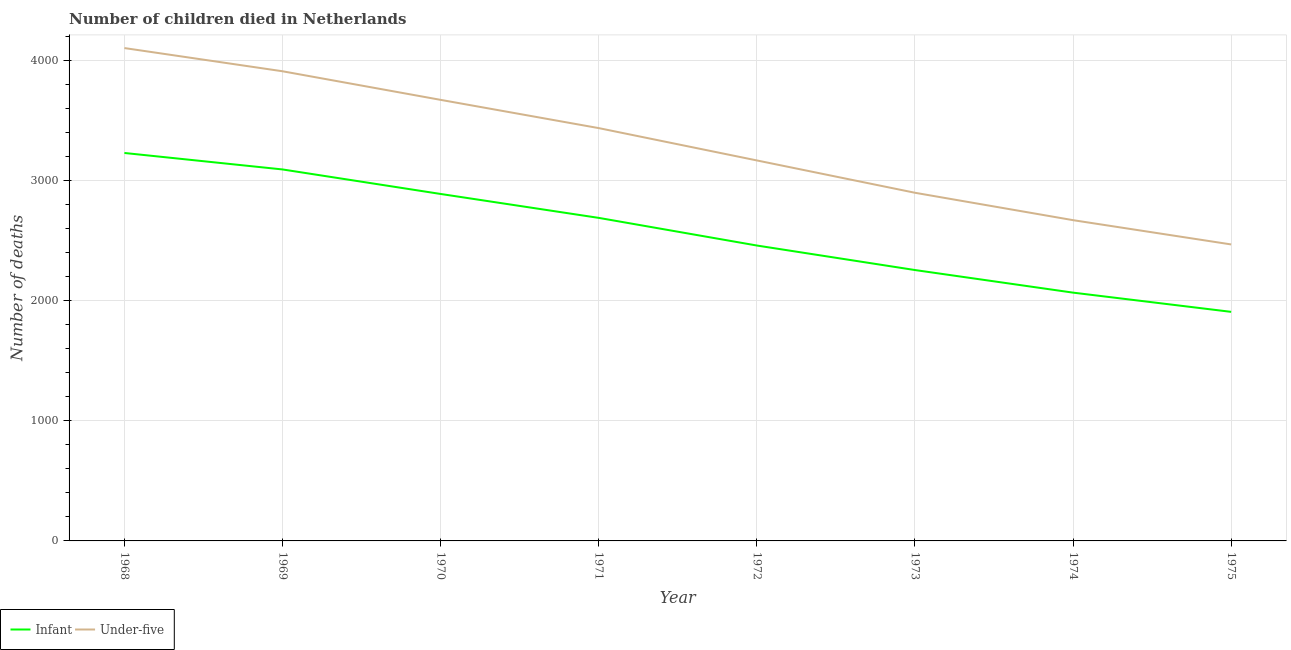Is the number of lines equal to the number of legend labels?
Offer a very short reply. Yes. What is the number of infant deaths in 1970?
Offer a terse response. 2887. Across all years, what is the maximum number of under-five deaths?
Provide a succinct answer. 4101. Across all years, what is the minimum number of under-five deaths?
Give a very brief answer. 2467. In which year was the number of infant deaths maximum?
Offer a very short reply. 1968. In which year was the number of infant deaths minimum?
Give a very brief answer. 1975. What is the total number of under-five deaths in the graph?
Ensure brevity in your answer.  2.63e+04. What is the difference between the number of infant deaths in 1968 and that in 1973?
Ensure brevity in your answer.  974. What is the difference between the number of infant deaths in 1971 and the number of under-five deaths in 1975?
Offer a terse response. 221. What is the average number of under-five deaths per year?
Provide a short and direct response. 3289.12. In the year 1972, what is the difference between the number of under-five deaths and number of infant deaths?
Keep it short and to the point. 708. What is the ratio of the number of under-five deaths in 1973 to that in 1975?
Ensure brevity in your answer.  1.17. Is the number of infant deaths in 1969 less than that in 1970?
Ensure brevity in your answer.  No. Is the difference between the number of under-five deaths in 1974 and 1975 greater than the difference between the number of infant deaths in 1974 and 1975?
Offer a very short reply. Yes. What is the difference between the highest and the second highest number of infant deaths?
Provide a succinct answer. 137. What is the difference between the highest and the lowest number of infant deaths?
Offer a very short reply. 1322. In how many years, is the number of infant deaths greater than the average number of infant deaths taken over all years?
Provide a short and direct response. 4. Is the sum of the number of infant deaths in 1969 and 1973 greater than the maximum number of under-five deaths across all years?
Make the answer very short. Yes. Does the number of infant deaths monotonically increase over the years?
Give a very brief answer. No. Is the number of under-five deaths strictly greater than the number of infant deaths over the years?
Ensure brevity in your answer.  Yes. How many lines are there?
Ensure brevity in your answer.  2. How many years are there in the graph?
Offer a very short reply. 8. What is the difference between two consecutive major ticks on the Y-axis?
Ensure brevity in your answer.  1000. Does the graph contain grids?
Offer a terse response. Yes. Where does the legend appear in the graph?
Provide a short and direct response. Bottom left. How many legend labels are there?
Offer a terse response. 2. How are the legend labels stacked?
Provide a short and direct response. Horizontal. What is the title of the graph?
Ensure brevity in your answer.  Number of children died in Netherlands. What is the label or title of the X-axis?
Keep it short and to the point. Year. What is the label or title of the Y-axis?
Your response must be concise. Number of deaths. What is the Number of deaths of Infant in 1968?
Offer a very short reply. 3228. What is the Number of deaths of Under-five in 1968?
Your response must be concise. 4101. What is the Number of deaths of Infant in 1969?
Your response must be concise. 3091. What is the Number of deaths in Under-five in 1969?
Your answer should be compact. 3908. What is the Number of deaths in Infant in 1970?
Offer a terse response. 2887. What is the Number of deaths in Under-five in 1970?
Offer a terse response. 3670. What is the Number of deaths in Infant in 1971?
Provide a short and direct response. 2688. What is the Number of deaths in Under-five in 1971?
Ensure brevity in your answer.  3435. What is the Number of deaths of Infant in 1972?
Your response must be concise. 2458. What is the Number of deaths of Under-five in 1972?
Your answer should be very brief. 3166. What is the Number of deaths in Infant in 1973?
Ensure brevity in your answer.  2254. What is the Number of deaths in Under-five in 1973?
Make the answer very short. 2897. What is the Number of deaths of Infant in 1974?
Give a very brief answer. 2066. What is the Number of deaths of Under-five in 1974?
Your response must be concise. 2669. What is the Number of deaths in Infant in 1975?
Your answer should be compact. 1906. What is the Number of deaths of Under-five in 1975?
Give a very brief answer. 2467. Across all years, what is the maximum Number of deaths of Infant?
Ensure brevity in your answer.  3228. Across all years, what is the maximum Number of deaths in Under-five?
Provide a short and direct response. 4101. Across all years, what is the minimum Number of deaths of Infant?
Offer a terse response. 1906. Across all years, what is the minimum Number of deaths in Under-five?
Provide a succinct answer. 2467. What is the total Number of deaths in Infant in the graph?
Ensure brevity in your answer.  2.06e+04. What is the total Number of deaths in Under-five in the graph?
Provide a succinct answer. 2.63e+04. What is the difference between the Number of deaths of Infant in 1968 and that in 1969?
Ensure brevity in your answer.  137. What is the difference between the Number of deaths of Under-five in 1968 and that in 1969?
Your response must be concise. 193. What is the difference between the Number of deaths in Infant in 1968 and that in 1970?
Your answer should be compact. 341. What is the difference between the Number of deaths in Under-five in 1968 and that in 1970?
Make the answer very short. 431. What is the difference between the Number of deaths of Infant in 1968 and that in 1971?
Offer a terse response. 540. What is the difference between the Number of deaths of Under-five in 1968 and that in 1971?
Provide a short and direct response. 666. What is the difference between the Number of deaths of Infant in 1968 and that in 1972?
Your answer should be compact. 770. What is the difference between the Number of deaths in Under-five in 1968 and that in 1972?
Your answer should be very brief. 935. What is the difference between the Number of deaths in Infant in 1968 and that in 1973?
Offer a terse response. 974. What is the difference between the Number of deaths in Under-five in 1968 and that in 1973?
Provide a short and direct response. 1204. What is the difference between the Number of deaths of Infant in 1968 and that in 1974?
Your answer should be very brief. 1162. What is the difference between the Number of deaths in Under-five in 1968 and that in 1974?
Provide a succinct answer. 1432. What is the difference between the Number of deaths in Infant in 1968 and that in 1975?
Provide a short and direct response. 1322. What is the difference between the Number of deaths in Under-five in 1968 and that in 1975?
Ensure brevity in your answer.  1634. What is the difference between the Number of deaths of Infant in 1969 and that in 1970?
Offer a terse response. 204. What is the difference between the Number of deaths of Under-five in 1969 and that in 1970?
Keep it short and to the point. 238. What is the difference between the Number of deaths of Infant in 1969 and that in 1971?
Your answer should be compact. 403. What is the difference between the Number of deaths of Under-five in 1969 and that in 1971?
Offer a terse response. 473. What is the difference between the Number of deaths of Infant in 1969 and that in 1972?
Ensure brevity in your answer.  633. What is the difference between the Number of deaths of Under-five in 1969 and that in 1972?
Give a very brief answer. 742. What is the difference between the Number of deaths in Infant in 1969 and that in 1973?
Offer a very short reply. 837. What is the difference between the Number of deaths in Under-five in 1969 and that in 1973?
Make the answer very short. 1011. What is the difference between the Number of deaths in Infant in 1969 and that in 1974?
Ensure brevity in your answer.  1025. What is the difference between the Number of deaths in Under-five in 1969 and that in 1974?
Offer a terse response. 1239. What is the difference between the Number of deaths of Infant in 1969 and that in 1975?
Keep it short and to the point. 1185. What is the difference between the Number of deaths in Under-five in 1969 and that in 1975?
Your answer should be very brief. 1441. What is the difference between the Number of deaths of Infant in 1970 and that in 1971?
Your answer should be very brief. 199. What is the difference between the Number of deaths of Under-five in 1970 and that in 1971?
Keep it short and to the point. 235. What is the difference between the Number of deaths of Infant in 1970 and that in 1972?
Offer a terse response. 429. What is the difference between the Number of deaths in Under-five in 1970 and that in 1972?
Make the answer very short. 504. What is the difference between the Number of deaths in Infant in 1970 and that in 1973?
Your answer should be very brief. 633. What is the difference between the Number of deaths of Under-five in 1970 and that in 1973?
Offer a terse response. 773. What is the difference between the Number of deaths of Infant in 1970 and that in 1974?
Your answer should be very brief. 821. What is the difference between the Number of deaths in Under-five in 1970 and that in 1974?
Provide a succinct answer. 1001. What is the difference between the Number of deaths of Infant in 1970 and that in 1975?
Provide a short and direct response. 981. What is the difference between the Number of deaths in Under-five in 1970 and that in 1975?
Give a very brief answer. 1203. What is the difference between the Number of deaths in Infant in 1971 and that in 1972?
Offer a very short reply. 230. What is the difference between the Number of deaths in Under-five in 1971 and that in 1972?
Make the answer very short. 269. What is the difference between the Number of deaths in Infant in 1971 and that in 1973?
Provide a succinct answer. 434. What is the difference between the Number of deaths in Under-five in 1971 and that in 1973?
Your answer should be compact. 538. What is the difference between the Number of deaths of Infant in 1971 and that in 1974?
Give a very brief answer. 622. What is the difference between the Number of deaths of Under-five in 1971 and that in 1974?
Provide a succinct answer. 766. What is the difference between the Number of deaths in Infant in 1971 and that in 1975?
Offer a terse response. 782. What is the difference between the Number of deaths of Under-five in 1971 and that in 1975?
Your answer should be very brief. 968. What is the difference between the Number of deaths in Infant in 1972 and that in 1973?
Your answer should be compact. 204. What is the difference between the Number of deaths in Under-five in 1972 and that in 1973?
Your answer should be very brief. 269. What is the difference between the Number of deaths in Infant in 1972 and that in 1974?
Provide a succinct answer. 392. What is the difference between the Number of deaths in Under-five in 1972 and that in 1974?
Your answer should be very brief. 497. What is the difference between the Number of deaths in Infant in 1972 and that in 1975?
Your response must be concise. 552. What is the difference between the Number of deaths in Under-five in 1972 and that in 1975?
Your answer should be very brief. 699. What is the difference between the Number of deaths of Infant in 1973 and that in 1974?
Your response must be concise. 188. What is the difference between the Number of deaths in Under-five in 1973 and that in 1974?
Ensure brevity in your answer.  228. What is the difference between the Number of deaths of Infant in 1973 and that in 1975?
Ensure brevity in your answer.  348. What is the difference between the Number of deaths in Under-five in 1973 and that in 1975?
Keep it short and to the point. 430. What is the difference between the Number of deaths in Infant in 1974 and that in 1975?
Your answer should be compact. 160. What is the difference between the Number of deaths of Under-five in 1974 and that in 1975?
Your response must be concise. 202. What is the difference between the Number of deaths in Infant in 1968 and the Number of deaths in Under-five in 1969?
Keep it short and to the point. -680. What is the difference between the Number of deaths of Infant in 1968 and the Number of deaths of Under-five in 1970?
Offer a very short reply. -442. What is the difference between the Number of deaths in Infant in 1968 and the Number of deaths in Under-five in 1971?
Give a very brief answer. -207. What is the difference between the Number of deaths of Infant in 1968 and the Number of deaths of Under-five in 1973?
Provide a short and direct response. 331. What is the difference between the Number of deaths in Infant in 1968 and the Number of deaths in Under-five in 1974?
Provide a short and direct response. 559. What is the difference between the Number of deaths in Infant in 1968 and the Number of deaths in Under-five in 1975?
Ensure brevity in your answer.  761. What is the difference between the Number of deaths in Infant in 1969 and the Number of deaths in Under-five in 1970?
Your answer should be very brief. -579. What is the difference between the Number of deaths of Infant in 1969 and the Number of deaths of Under-five in 1971?
Offer a very short reply. -344. What is the difference between the Number of deaths of Infant in 1969 and the Number of deaths of Under-five in 1972?
Give a very brief answer. -75. What is the difference between the Number of deaths in Infant in 1969 and the Number of deaths in Under-five in 1973?
Your response must be concise. 194. What is the difference between the Number of deaths in Infant in 1969 and the Number of deaths in Under-five in 1974?
Make the answer very short. 422. What is the difference between the Number of deaths of Infant in 1969 and the Number of deaths of Under-five in 1975?
Provide a short and direct response. 624. What is the difference between the Number of deaths in Infant in 1970 and the Number of deaths in Under-five in 1971?
Give a very brief answer. -548. What is the difference between the Number of deaths of Infant in 1970 and the Number of deaths of Under-five in 1972?
Offer a very short reply. -279. What is the difference between the Number of deaths of Infant in 1970 and the Number of deaths of Under-five in 1973?
Provide a short and direct response. -10. What is the difference between the Number of deaths of Infant in 1970 and the Number of deaths of Under-five in 1974?
Ensure brevity in your answer.  218. What is the difference between the Number of deaths of Infant in 1970 and the Number of deaths of Under-five in 1975?
Provide a succinct answer. 420. What is the difference between the Number of deaths of Infant in 1971 and the Number of deaths of Under-five in 1972?
Provide a succinct answer. -478. What is the difference between the Number of deaths of Infant in 1971 and the Number of deaths of Under-five in 1973?
Give a very brief answer. -209. What is the difference between the Number of deaths of Infant in 1971 and the Number of deaths of Under-five in 1974?
Your answer should be compact. 19. What is the difference between the Number of deaths in Infant in 1971 and the Number of deaths in Under-five in 1975?
Offer a terse response. 221. What is the difference between the Number of deaths in Infant in 1972 and the Number of deaths in Under-five in 1973?
Provide a succinct answer. -439. What is the difference between the Number of deaths of Infant in 1972 and the Number of deaths of Under-five in 1974?
Keep it short and to the point. -211. What is the difference between the Number of deaths of Infant in 1973 and the Number of deaths of Under-five in 1974?
Keep it short and to the point. -415. What is the difference between the Number of deaths of Infant in 1973 and the Number of deaths of Under-five in 1975?
Give a very brief answer. -213. What is the difference between the Number of deaths in Infant in 1974 and the Number of deaths in Under-five in 1975?
Keep it short and to the point. -401. What is the average Number of deaths in Infant per year?
Your response must be concise. 2572.25. What is the average Number of deaths of Under-five per year?
Keep it short and to the point. 3289.12. In the year 1968, what is the difference between the Number of deaths in Infant and Number of deaths in Under-five?
Provide a succinct answer. -873. In the year 1969, what is the difference between the Number of deaths in Infant and Number of deaths in Under-five?
Provide a succinct answer. -817. In the year 1970, what is the difference between the Number of deaths in Infant and Number of deaths in Under-five?
Give a very brief answer. -783. In the year 1971, what is the difference between the Number of deaths in Infant and Number of deaths in Under-five?
Make the answer very short. -747. In the year 1972, what is the difference between the Number of deaths in Infant and Number of deaths in Under-five?
Offer a terse response. -708. In the year 1973, what is the difference between the Number of deaths of Infant and Number of deaths of Under-five?
Make the answer very short. -643. In the year 1974, what is the difference between the Number of deaths of Infant and Number of deaths of Under-five?
Your response must be concise. -603. In the year 1975, what is the difference between the Number of deaths of Infant and Number of deaths of Under-five?
Keep it short and to the point. -561. What is the ratio of the Number of deaths in Infant in 1968 to that in 1969?
Offer a terse response. 1.04. What is the ratio of the Number of deaths in Under-five in 1968 to that in 1969?
Your response must be concise. 1.05. What is the ratio of the Number of deaths in Infant in 1968 to that in 1970?
Your response must be concise. 1.12. What is the ratio of the Number of deaths in Under-five in 1968 to that in 1970?
Offer a very short reply. 1.12. What is the ratio of the Number of deaths of Infant in 1968 to that in 1971?
Your answer should be compact. 1.2. What is the ratio of the Number of deaths of Under-five in 1968 to that in 1971?
Your answer should be compact. 1.19. What is the ratio of the Number of deaths of Infant in 1968 to that in 1972?
Provide a succinct answer. 1.31. What is the ratio of the Number of deaths of Under-five in 1968 to that in 1972?
Provide a short and direct response. 1.3. What is the ratio of the Number of deaths in Infant in 1968 to that in 1973?
Provide a succinct answer. 1.43. What is the ratio of the Number of deaths in Under-five in 1968 to that in 1973?
Ensure brevity in your answer.  1.42. What is the ratio of the Number of deaths of Infant in 1968 to that in 1974?
Give a very brief answer. 1.56. What is the ratio of the Number of deaths in Under-five in 1968 to that in 1974?
Give a very brief answer. 1.54. What is the ratio of the Number of deaths in Infant in 1968 to that in 1975?
Ensure brevity in your answer.  1.69. What is the ratio of the Number of deaths of Under-five in 1968 to that in 1975?
Keep it short and to the point. 1.66. What is the ratio of the Number of deaths in Infant in 1969 to that in 1970?
Your answer should be very brief. 1.07. What is the ratio of the Number of deaths in Under-five in 1969 to that in 1970?
Offer a very short reply. 1.06. What is the ratio of the Number of deaths in Infant in 1969 to that in 1971?
Your answer should be compact. 1.15. What is the ratio of the Number of deaths in Under-five in 1969 to that in 1971?
Provide a succinct answer. 1.14. What is the ratio of the Number of deaths of Infant in 1969 to that in 1972?
Your answer should be compact. 1.26. What is the ratio of the Number of deaths in Under-five in 1969 to that in 1972?
Your answer should be compact. 1.23. What is the ratio of the Number of deaths of Infant in 1969 to that in 1973?
Offer a very short reply. 1.37. What is the ratio of the Number of deaths in Under-five in 1969 to that in 1973?
Offer a very short reply. 1.35. What is the ratio of the Number of deaths of Infant in 1969 to that in 1974?
Your answer should be compact. 1.5. What is the ratio of the Number of deaths in Under-five in 1969 to that in 1974?
Offer a terse response. 1.46. What is the ratio of the Number of deaths of Infant in 1969 to that in 1975?
Offer a terse response. 1.62. What is the ratio of the Number of deaths in Under-five in 1969 to that in 1975?
Keep it short and to the point. 1.58. What is the ratio of the Number of deaths of Infant in 1970 to that in 1971?
Ensure brevity in your answer.  1.07. What is the ratio of the Number of deaths in Under-five in 1970 to that in 1971?
Your response must be concise. 1.07. What is the ratio of the Number of deaths in Infant in 1970 to that in 1972?
Make the answer very short. 1.17. What is the ratio of the Number of deaths in Under-five in 1970 to that in 1972?
Provide a short and direct response. 1.16. What is the ratio of the Number of deaths of Infant in 1970 to that in 1973?
Your answer should be very brief. 1.28. What is the ratio of the Number of deaths of Under-five in 1970 to that in 1973?
Offer a very short reply. 1.27. What is the ratio of the Number of deaths of Infant in 1970 to that in 1974?
Make the answer very short. 1.4. What is the ratio of the Number of deaths in Under-five in 1970 to that in 1974?
Offer a very short reply. 1.38. What is the ratio of the Number of deaths of Infant in 1970 to that in 1975?
Provide a short and direct response. 1.51. What is the ratio of the Number of deaths of Under-five in 1970 to that in 1975?
Your response must be concise. 1.49. What is the ratio of the Number of deaths of Infant in 1971 to that in 1972?
Provide a succinct answer. 1.09. What is the ratio of the Number of deaths of Under-five in 1971 to that in 1972?
Make the answer very short. 1.08. What is the ratio of the Number of deaths of Infant in 1971 to that in 1973?
Provide a succinct answer. 1.19. What is the ratio of the Number of deaths in Under-five in 1971 to that in 1973?
Your answer should be very brief. 1.19. What is the ratio of the Number of deaths of Infant in 1971 to that in 1974?
Offer a terse response. 1.3. What is the ratio of the Number of deaths in Under-five in 1971 to that in 1974?
Ensure brevity in your answer.  1.29. What is the ratio of the Number of deaths of Infant in 1971 to that in 1975?
Ensure brevity in your answer.  1.41. What is the ratio of the Number of deaths of Under-five in 1971 to that in 1975?
Keep it short and to the point. 1.39. What is the ratio of the Number of deaths in Infant in 1972 to that in 1973?
Offer a terse response. 1.09. What is the ratio of the Number of deaths in Under-five in 1972 to that in 1973?
Your answer should be very brief. 1.09. What is the ratio of the Number of deaths of Infant in 1972 to that in 1974?
Your response must be concise. 1.19. What is the ratio of the Number of deaths in Under-five in 1972 to that in 1974?
Provide a succinct answer. 1.19. What is the ratio of the Number of deaths of Infant in 1972 to that in 1975?
Your answer should be compact. 1.29. What is the ratio of the Number of deaths of Under-five in 1972 to that in 1975?
Provide a succinct answer. 1.28. What is the ratio of the Number of deaths of Infant in 1973 to that in 1974?
Provide a short and direct response. 1.09. What is the ratio of the Number of deaths in Under-five in 1973 to that in 1974?
Your answer should be very brief. 1.09. What is the ratio of the Number of deaths in Infant in 1973 to that in 1975?
Make the answer very short. 1.18. What is the ratio of the Number of deaths in Under-five in 1973 to that in 1975?
Make the answer very short. 1.17. What is the ratio of the Number of deaths of Infant in 1974 to that in 1975?
Ensure brevity in your answer.  1.08. What is the ratio of the Number of deaths in Under-five in 1974 to that in 1975?
Provide a succinct answer. 1.08. What is the difference between the highest and the second highest Number of deaths in Infant?
Make the answer very short. 137. What is the difference between the highest and the second highest Number of deaths of Under-five?
Your answer should be very brief. 193. What is the difference between the highest and the lowest Number of deaths in Infant?
Offer a very short reply. 1322. What is the difference between the highest and the lowest Number of deaths of Under-five?
Your answer should be very brief. 1634. 